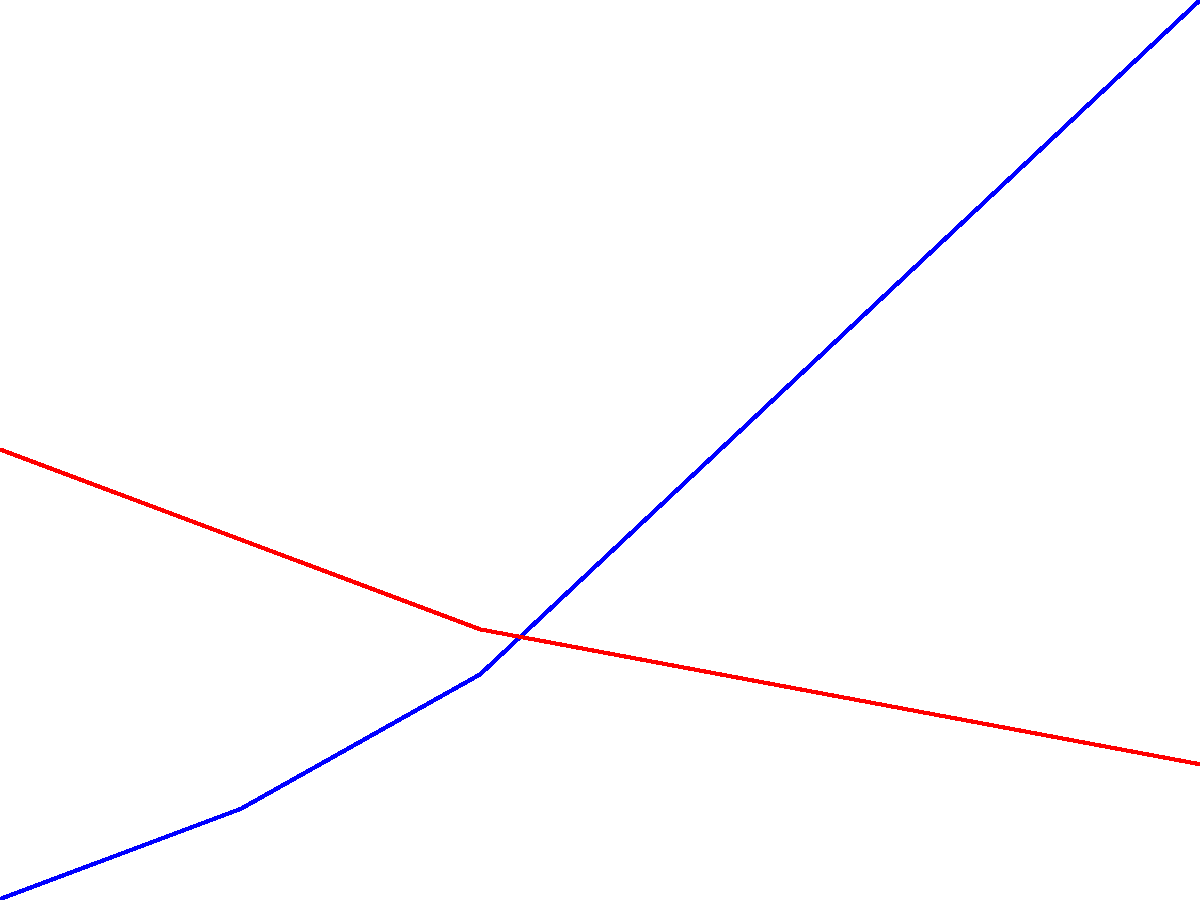Based on the line graph showing sales trends of vinyl records over six months, what strategic decision should you make regarding stock allocation between indie and pop genres for the upcoming month? To answer this question, let's analyze the trends for both genres:

1. Indie records:
   - Starting at 100 units in month 1
   - Steadily increasing each month
   - Reaching 300 units by month 6
   - Shows a clear upward trend

2. Pop records:
   - Starting at 200 units in month 1
   - Consistently decreasing each month
   - Dropping to 130 units by month 6
   - Shows a clear downward trend

3. Comparing trends:
   - Indie records are gaining popularity
   - Pop records are losing popularity
   - The trends intersect around month 3-4

4. Strategic decision:
   - Given the opposite trends, it's clear that indie records are becoming more popular while pop records are declining in sales
   - As a record store owner with insider information, you should capitalize on the growing trend

5. Conclusion:
   - Allocate more stock to indie records for the upcoming month
   - Reduce stock of pop records to minimize potential losses

This strategy aligns with the observed trends and maximizes potential profits based on the sales data.
Answer: Allocate more stock to indie records, reduce pop records stock 